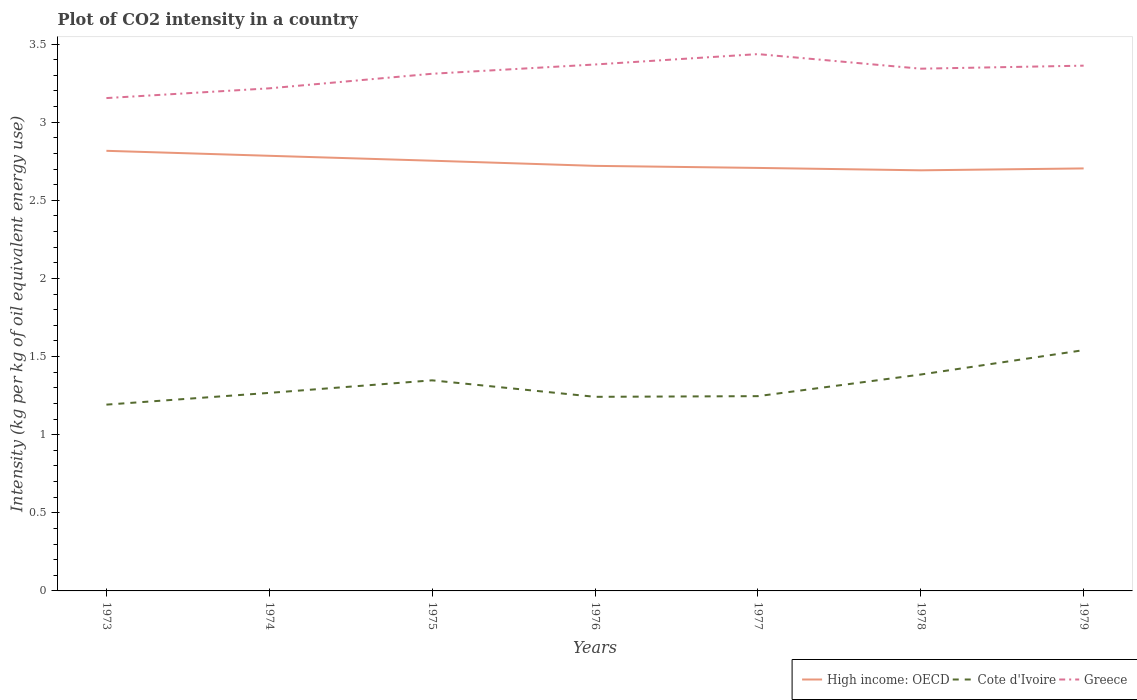Does the line corresponding to Greece intersect with the line corresponding to High income: OECD?
Keep it short and to the point. No. Across all years, what is the maximum CO2 intensity in in High income: OECD?
Your answer should be very brief. 2.69. In which year was the CO2 intensity in in Greece maximum?
Make the answer very short. 1973. What is the total CO2 intensity in in Greece in the graph?
Make the answer very short. 0.07. What is the difference between the highest and the second highest CO2 intensity in in Cote d'Ivoire?
Make the answer very short. 0.35. What is the difference between the highest and the lowest CO2 intensity in in Cote d'Ivoire?
Your response must be concise. 3. Is the CO2 intensity in in Cote d'Ivoire strictly greater than the CO2 intensity in in Greece over the years?
Your response must be concise. Yes. How many lines are there?
Provide a short and direct response. 3. Does the graph contain grids?
Your answer should be very brief. No. What is the title of the graph?
Ensure brevity in your answer.  Plot of CO2 intensity in a country. Does "Rwanda" appear as one of the legend labels in the graph?
Make the answer very short. No. What is the label or title of the X-axis?
Give a very brief answer. Years. What is the label or title of the Y-axis?
Your answer should be compact. Intensity (kg per kg of oil equivalent energy use). What is the Intensity (kg per kg of oil equivalent energy use) in High income: OECD in 1973?
Give a very brief answer. 2.82. What is the Intensity (kg per kg of oil equivalent energy use) in Cote d'Ivoire in 1973?
Your response must be concise. 1.19. What is the Intensity (kg per kg of oil equivalent energy use) of Greece in 1973?
Offer a terse response. 3.15. What is the Intensity (kg per kg of oil equivalent energy use) in High income: OECD in 1974?
Offer a terse response. 2.78. What is the Intensity (kg per kg of oil equivalent energy use) in Cote d'Ivoire in 1974?
Offer a terse response. 1.27. What is the Intensity (kg per kg of oil equivalent energy use) of Greece in 1974?
Offer a very short reply. 3.22. What is the Intensity (kg per kg of oil equivalent energy use) of High income: OECD in 1975?
Your answer should be very brief. 2.75. What is the Intensity (kg per kg of oil equivalent energy use) of Cote d'Ivoire in 1975?
Make the answer very short. 1.35. What is the Intensity (kg per kg of oil equivalent energy use) of Greece in 1975?
Offer a terse response. 3.31. What is the Intensity (kg per kg of oil equivalent energy use) of High income: OECD in 1976?
Offer a terse response. 2.72. What is the Intensity (kg per kg of oil equivalent energy use) in Cote d'Ivoire in 1976?
Keep it short and to the point. 1.24. What is the Intensity (kg per kg of oil equivalent energy use) of Greece in 1976?
Keep it short and to the point. 3.37. What is the Intensity (kg per kg of oil equivalent energy use) of High income: OECD in 1977?
Keep it short and to the point. 2.71. What is the Intensity (kg per kg of oil equivalent energy use) in Cote d'Ivoire in 1977?
Provide a succinct answer. 1.25. What is the Intensity (kg per kg of oil equivalent energy use) of Greece in 1977?
Provide a short and direct response. 3.44. What is the Intensity (kg per kg of oil equivalent energy use) of High income: OECD in 1978?
Provide a short and direct response. 2.69. What is the Intensity (kg per kg of oil equivalent energy use) of Cote d'Ivoire in 1978?
Your response must be concise. 1.39. What is the Intensity (kg per kg of oil equivalent energy use) of Greece in 1978?
Ensure brevity in your answer.  3.34. What is the Intensity (kg per kg of oil equivalent energy use) in High income: OECD in 1979?
Your response must be concise. 2.7. What is the Intensity (kg per kg of oil equivalent energy use) in Cote d'Ivoire in 1979?
Provide a succinct answer. 1.54. What is the Intensity (kg per kg of oil equivalent energy use) of Greece in 1979?
Offer a very short reply. 3.36. Across all years, what is the maximum Intensity (kg per kg of oil equivalent energy use) of High income: OECD?
Make the answer very short. 2.82. Across all years, what is the maximum Intensity (kg per kg of oil equivalent energy use) of Cote d'Ivoire?
Offer a very short reply. 1.54. Across all years, what is the maximum Intensity (kg per kg of oil equivalent energy use) in Greece?
Give a very brief answer. 3.44. Across all years, what is the minimum Intensity (kg per kg of oil equivalent energy use) in High income: OECD?
Make the answer very short. 2.69. Across all years, what is the minimum Intensity (kg per kg of oil equivalent energy use) in Cote d'Ivoire?
Your answer should be very brief. 1.19. Across all years, what is the minimum Intensity (kg per kg of oil equivalent energy use) in Greece?
Your answer should be very brief. 3.15. What is the total Intensity (kg per kg of oil equivalent energy use) of High income: OECD in the graph?
Offer a terse response. 19.18. What is the total Intensity (kg per kg of oil equivalent energy use) in Cote d'Ivoire in the graph?
Your answer should be very brief. 9.22. What is the total Intensity (kg per kg of oil equivalent energy use) in Greece in the graph?
Ensure brevity in your answer.  23.19. What is the difference between the Intensity (kg per kg of oil equivalent energy use) of High income: OECD in 1973 and that in 1974?
Your response must be concise. 0.03. What is the difference between the Intensity (kg per kg of oil equivalent energy use) in Cote d'Ivoire in 1973 and that in 1974?
Offer a terse response. -0.08. What is the difference between the Intensity (kg per kg of oil equivalent energy use) in Greece in 1973 and that in 1974?
Your answer should be very brief. -0.06. What is the difference between the Intensity (kg per kg of oil equivalent energy use) in High income: OECD in 1973 and that in 1975?
Your response must be concise. 0.06. What is the difference between the Intensity (kg per kg of oil equivalent energy use) of Cote d'Ivoire in 1973 and that in 1975?
Give a very brief answer. -0.16. What is the difference between the Intensity (kg per kg of oil equivalent energy use) of Greece in 1973 and that in 1975?
Your answer should be very brief. -0.16. What is the difference between the Intensity (kg per kg of oil equivalent energy use) in High income: OECD in 1973 and that in 1976?
Offer a terse response. 0.1. What is the difference between the Intensity (kg per kg of oil equivalent energy use) of Cote d'Ivoire in 1973 and that in 1976?
Your answer should be compact. -0.05. What is the difference between the Intensity (kg per kg of oil equivalent energy use) in Greece in 1973 and that in 1976?
Provide a succinct answer. -0.21. What is the difference between the Intensity (kg per kg of oil equivalent energy use) of High income: OECD in 1973 and that in 1977?
Give a very brief answer. 0.11. What is the difference between the Intensity (kg per kg of oil equivalent energy use) in Cote d'Ivoire in 1973 and that in 1977?
Make the answer very short. -0.05. What is the difference between the Intensity (kg per kg of oil equivalent energy use) in Greece in 1973 and that in 1977?
Your answer should be very brief. -0.28. What is the difference between the Intensity (kg per kg of oil equivalent energy use) in High income: OECD in 1973 and that in 1978?
Give a very brief answer. 0.12. What is the difference between the Intensity (kg per kg of oil equivalent energy use) in Cote d'Ivoire in 1973 and that in 1978?
Provide a succinct answer. -0.19. What is the difference between the Intensity (kg per kg of oil equivalent energy use) in Greece in 1973 and that in 1978?
Your answer should be very brief. -0.19. What is the difference between the Intensity (kg per kg of oil equivalent energy use) in High income: OECD in 1973 and that in 1979?
Ensure brevity in your answer.  0.11. What is the difference between the Intensity (kg per kg of oil equivalent energy use) of Cote d'Ivoire in 1973 and that in 1979?
Your answer should be compact. -0.35. What is the difference between the Intensity (kg per kg of oil equivalent energy use) in Greece in 1973 and that in 1979?
Make the answer very short. -0.21. What is the difference between the Intensity (kg per kg of oil equivalent energy use) in High income: OECD in 1974 and that in 1975?
Your answer should be compact. 0.03. What is the difference between the Intensity (kg per kg of oil equivalent energy use) in Cote d'Ivoire in 1974 and that in 1975?
Offer a terse response. -0.08. What is the difference between the Intensity (kg per kg of oil equivalent energy use) of Greece in 1974 and that in 1975?
Ensure brevity in your answer.  -0.09. What is the difference between the Intensity (kg per kg of oil equivalent energy use) in High income: OECD in 1974 and that in 1976?
Ensure brevity in your answer.  0.06. What is the difference between the Intensity (kg per kg of oil equivalent energy use) in Cote d'Ivoire in 1974 and that in 1976?
Your response must be concise. 0.03. What is the difference between the Intensity (kg per kg of oil equivalent energy use) of Greece in 1974 and that in 1976?
Your answer should be compact. -0.15. What is the difference between the Intensity (kg per kg of oil equivalent energy use) of High income: OECD in 1974 and that in 1977?
Keep it short and to the point. 0.08. What is the difference between the Intensity (kg per kg of oil equivalent energy use) of Cote d'Ivoire in 1974 and that in 1977?
Offer a terse response. 0.02. What is the difference between the Intensity (kg per kg of oil equivalent energy use) in Greece in 1974 and that in 1977?
Offer a terse response. -0.22. What is the difference between the Intensity (kg per kg of oil equivalent energy use) in High income: OECD in 1974 and that in 1978?
Your answer should be compact. 0.09. What is the difference between the Intensity (kg per kg of oil equivalent energy use) of Cote d'Ivoire in 1974 and that in 1978?
Your answer should be very brief. -0.12. What is the difference between the Intensity (kg per kg of oil equivalent energy use) in Greece in 1974 and that in 1978?
Your response must be concise. -0.13. What is the difference between the Intensity (kg per kg of oil equivalent energy use) in High income: OECD in 1974 and that in 1979?
Make the answer very short. 0.08. What is the difference between the Intensity (kg per kg of oil equivalent energy use) of Cote d'Ivoire in 1974 and that in 1979?
Make the answer very short. -0.27. What is the difference between the Intensity (kg per kg of oil equivalent energy use) of Greece in 1974 and that in 1979?
Keep it short and to the point. -0.15. What is the difference between the Intensity (kg per kg of oil equivalent energy use) of High income: OECD in 1975 and that in 1976?
Ensure brevity in your answer.  0.03. What is the difference between the Intensity (kg per kg of oil equivalent energy use) in Cote d'Ivoire in 1975 and that in 1976?
Your answer should be compact. 0.11. What is the difference between the Intensity (kg per kg of oil equivalent energy use) of Greece in 1975 and that in 1976?
Your answer should be very brief. -0.06. What is the difference between the Intensity (kg per kg of oil equivalent energy use) in High income: OECD in 1975 and that in 1977?
Provide a succinct answer. 0.05. What is the difference between the Intensity (kg per kg of oil equivalent energy use) in Cote d'Ivoire in 1975 and that in 1977?
Make the answer very short. 0.1. What is the difference between the Intensity (kg per kg of oil equivalent energy use) of Greece in 1975 and that in 1977?
Provide a succinct answer. -0.13. What is the difference between the Intensity (kg per kg of oil equivalent energy use) of High income: OECD in 1975 and that in 1978?
Give a very brief answer. 0.06. What is the difference between the Intensity (kg per kg of oil equivalent energy use) of Cote d'Ivoire in 1975 and that in 1978?
Your answer should be very brief. -0.04. What is the difference between the Intensity (kg per kg of oil equivalent energy use) of Greece in 1975 and that in 1978?
Provide a short and direct response. -0.03. What is the difference between the Intensity (kg per kg of oil equivalent energy use) in High income: OECD in 1975 and that in 1979?
Provide a succinct answer. 0.05. What is the difference between the Intensity (kg per kg of oil equivalent energy use) of Cote d'Ivoire in 1975 and that in 1979?
Give a very brief answer. -0.19. What is the difference between the Intensity (kg per kg of oil equivalent energy use) of Greece in 1975 and that in 1979?
Your answer should be compact. -0.05. What is the difference between the Intensity (kg per kg of oil equivalent energy use) in High income: OECD in 1976 and that in 1977?
Ensure brevity in your answer.  0.01. What is the difference between the Intensity (kg per kg of oil equivalent energy use) of Cote d'Ivoire in 1976 and that in 1977?
Ensure brevity in your answer.  -0. What is the difference between the Intensity (kg per kg of oil equivalent energy use) of Greece in 1976 and that in 1977?
Offer a very short reply. -0.07. What is the difference between the Intensity (kg per kg of oil equivalent energy use) in High income: OECD in 1976 and that in 1978?
Offer a terse response. 0.03. What is the difference between the Intensity (kg per kg of oil equivalent energy use) of Cote d'Ivoire in 1976 and that in 1978?
Provide a succinct answer. -0.14. What is the difference between the Intensity (kg per kg of oil equivalent energy use) in Greece in 1976 and that in 1978?
Make the answer very short. 0.03. What is the difference between the Intensity (kg per kg of oil equivalent energy use) in High income: OECD in 1976 and that in 1979?
Your answer should be very brief. 0.02. What is the difference between the Intensity (kg per kg of oil equivalent energy use) in Cote d'Ivoire in 1976 and that in 1979?
Give a very brief answer. -0.3. What is the difference between the Intensity (kg per kg of oil equivalent energy use) of Greece in 1976 and that in 1979?
Provide a short and direct response. 0.01. What is the difference between the Intensity (kg per kg of oil equivalent energy use) of High income: OECD in 1977 and that in 1978?
Offer a very short reply. 0.02. What is the difference between the Intensity (kg per kg of oil equivalent energy use) of Cote d'Ivoire in 1977 and that in 1978?
Keep it short and to the point. -0.14. What is the difference between the Intensity (kg per kg of oil equivalent energy use) of Greece in 1977 and that in 1978?
Make the answer very short. 0.09. What is the difference between the Intensity (kg per kg of oil equivalent energy use) of High income: OECD in 1977 and that in 1979?
Your answer should be very brief. 0. What is the difference between the Intensity (kg per kg of oil equivalent energy use) of Cote d'Ivoire in 1977 and that in 1979?
Give a very brief answer. -0.29. What is the difference between the Intensity (kg per kg of oil equivalent energy use) of Greece in 1977 and that in 1979?
Keep it short and to the point. 0.07. What is the difference between the Intensity (kg per kg of oil equivalent energy use) of High income: OECD in 1978 and that in 1979?
Your answer should be very brief. -0.01. What is the difference between the Intensity (kg per kg of oil equivalent energy use) of Cote d'Ivoire in 1978 and that in 1979?
Offer a terse response. -0.16. What is the difference between the Intensity (kg per kg of oil equivalent energy use) in Greece in 1978 and that in 1979?
Offer a very short reply. -0.02. What is the difference between the Intensity (kg per kg of oil equivalent energy use) in High income: OECD in 1973 and the Intensity (kg per kg of oil equivalent energy use) in Cote d'Ivoire in 1974?
Your answer should be compact. 1.55. What is the difference between the Intensity (kg per kg of oil equivalent energy use) of High income: OECD in 1973 and the Intensity (kg per kg of oil equivalent energy use) of Greece in 1974?
Your answer should be very brief. -0.4. What is the difference between the Intensity (kg per kg of oil equivalent energy use) in Cote d'Ivoire in 1973 and the Intensity (kg per kg of oil equivalent energy use) in Greece in 1974?
Offer a terse response. -2.02. What is the difference between the Intensity (kg per kg of oil equivalent energy use) of High income: OECD in 1973 and the Intensity (kg per kg of oil equivalent energy use) of Cote d'Ivoire in 1975?
Your answer should be very brief. 1.47. What is the difference between the Intensity (kg per kg of oil equivalent energy use) in High income: OECD in 1973 and the Intensity (kg per kg of oil equivalent energy use) in Greece in 1975?
Your answer should be compact. -0.49. What is the difference between the Intensity (kg per kg of oil equivalent energy use) in Cote d'Ivoire in 1973 and the Intensity (kg per kg of oil equivalent energy use) in Greece in 1975?
Provide a short and direct response. -2.12. What is the difference between the Intensity (kg per kg of oil equivalent energy use) in High income: OECD in 1973 and the Intensity (kg per kg of oil equivalent energy use) in Cote d'Ivoire in 1976?
Ensure brevity in your answer.  1.57. What is the difference between the Intensity (kg per kg of oil equivalent energy use) in High income: OECD in 1973 and the Intensity (kg per kg of oil equivalent energy use) in Greece in 1976?
Provide a succinct answer. -0.55. What is the difference between the Intensity (kg per kg of oil equivalent energy use) in Cote d'Ivoire in 1973 and the Intensity (kg per kg of oil equivalent energy use) in Greece in 1976?
Make the answer very short. -2.18. What is the difference between the Intensity (kg per kg of oil equivalent energy use) in High income: OECD in 1973 and the Intensity (kg per kg of oil equivalent energy use) in Cote d'Ivoire in 1977?
Offer a very short reply. 1.57. What is the difference between the Intensity (kg per kg of oil equivalent energy use) of High income: OECD in 1973 and the Intensity (kg per kg of oil equivalent energy use) of Greece in 1977?
Offer a very short reply. -0.62. What is the difference between the Intensity (kg per kg of oil equivalent energy use) in Cote d'Ivoire in 1973 and the Intensity (kg per kg of oil equivalent energy use) in Greece in 1977?
Offer a terse response. -2.24. What is the difference between the Intensity (kg per kg of oil equivalent energy use) in High income: OECD in 1973 and the Intensity (kg per kg of oil equivalent energy use) in Cote d'Ivoire in 1978?
Give a very brief answer. 1.43. What is the difference between the Intensity (kg per kg of oil equivalent energy use) in High income: OECD in 1973 and the Intensity (kg per kg of oil equivalent energy use) in Greece in 1978?
Make the answer very short. -0.53. What is the difference between the Intensity (kg per kg of oil equivalent energy use) of Cote d'Ivoire in 1973 and the Intensity (kg per kg of oil equivalent energy use) of Greece in 1978?
Provide a short and direct response. -2.15. What is the difference between the Intensity (kg per kg of oil equivalent energy use) in High income: OECD in 1973 and the Intensity (kg per kg of oil equivalent energy use) in Cote d'Ivoire in 1979?
Your answer should be compact. 1.28. What is the difference between the Intensity (kg per kg of oil equivalent energy use) of High income: OECD in 1973 and the Intensity (kg per kg of oil equivalent energy use) of Greece in 1979?
Provide a short and direct response. -0.55. What is the difference between the Intensity (kg per kg of oil equivalent energy use) in Cote d'Ivoire in 1973 and the Intensity (kg per kg of oil equivalent energy use) in Greece in 1979?
Provide a short and direct response. -2.17. What is the difference between the Intensity (kg per kg of oil equivalent energy use) of High income: OECD in 1974 and the Intensity (kg per kg of oil equivalent energy use) of Cote d'Ivoire in 1975?
Offer a very short reply. 1.44. What is the difference between the Intensity (kg per kg of oil equivalent energy use) in High income: OECD in 1974 and the Intensity (kg per kg of oil equivalent energy use) in Greece in 1975?
Offer a very short reply. -0.53. What is the difference between the Intensity (kg per kg of oil equivalent energy use) of Cote d'Ivoire in 1974 and the Intensity (kg per kg of oil equivalent energy use) of Greece in 1975?
Your response must be concise. -2.04. What is the difference between the Intensity (kg per kg of oil equivalent energy use) of High income: OECD in 1974 and the Intensity (kg per kg of oil equivalent energy use) of Cote d'Ivoire in 1976?
Your answer should be very brief. 1.54. What is the difference between the Intensity (kg per kg of oil equivalent energy use) in High income: OECD in 1974 and the Intensity (kg per kg of oil equivalent energy use) in Greece in 1976?
Ensure brevity in your answer.  -0.58. What is the difference between the Intensity (kg per kg of oil equivalent energy use) of Cote d'Ivoire in 1974 and the Intensity (kg per kg of oil equivalent energy use) of Greece in 1976?
Make the answer very short. -2.1. What is the difference between the Intensity (kg per kg of oil equivalent energy use) of High income: OECD in 1974 and the Intensity (kg per kg of oil equivalent energy use) of Cote d'Ivoire in 1977?
Your answer should be compact. 1.54. What is the difference between the Intensity (kg per kg of oil equivalent energy use) of High income: OECD in 1974 and the Intensity (kg per kg of oil equivalent energy use) of Greece in 1977?
Provide a short and direct response. -0.65. What is the difference between the Intensity (kg per kg of oil equivalent energy use) in Cote d'Ivoire in 1974 and the Intensity (kg per kg of oil equivalent energy use) in Greece in 1977?
Your answer should be very brief. -2.17. What is the difference between the Intensity (kg per kg of oil equivalent energy use) in High income: OECD in 1974 and the Intensity (kg per kg of oil equivalent energy use) in Cote d'Ivoire in 1978?
Offer a very short reply. 1.4. What is the difference between the Intensity (kg per kg of oil equivalent energy use) of High income: OECD in 1974 and the Intensity (kg per kg of oil equivalent energy use) of Greece in 1978?
Your answer should be very brief. -0.56. What is the difference between the Intensity (kg per kg of oil equivalent energy use) in Cote d'Ivoire in 1974 and the Intensity (kg per kg of oil equivalent energy use) in Greece in 1978?
Ensure brevity in your answer.  -2.08. What is the difference between the Intensity (kg per kg of oil equivalent energy use) in High income: OECD in 1974 and the Intensity (kg per kg of oil equivalent energy use) in Cote d'Ivoire in 1979?
Give a very brief answer. 1.24. What is the difference between the Intensity (kg per kg of oil equivalent energy use) of High income: OECD in 1974 and the Intensity (kg per kg of oil equivalent energy use) of Greece in 1979?
Your answer should be very brief. -0.58. What is the difference between the Intensity (kg per kg of oil equivalent energy use) of Cote d'Ivoire in 1974 and the Intensity (kg per kg of oil equivalent energy use) of Greece in 1979?
Your answer should be very brief. -2.09. What is the difference between the Intensity (kg per kg of oil equivalent energy use) in High income: OECD in 1975 and the Intensity (kg per kg of oil equivalent energy use) in Cote d'Ivoire in 1976?
Your answer should be very brief. 1.51. What is the difference between the Intensity (kg per kg of oil equivalent energy use) of High income: OECD in 1975 and the Intensity (kg per kg of oil equivalent energy use) of Greece in 1976?
Offer a terse response. -0.62. What is the difference between the Intensity (kg per kg of oil equivalent energy use) in Cote d'Ivoire in 1975 and the Intensity (kg per kg of oil equivalent energy use) in Greece in 1976?
Keep it short and to the point. -2.02. What is the difference between the Intensity (kg per kg of oil equivalent energy use) in High income: OECD in 1975 and the Intensity (kg per kg of oil equivalent energy use) in Cote d'Ivoire in 1977?
Ensure brevity in your answer.  1.51. What is the difference between the Intensity (kg per kg of oil equivalent energy use) in High income: OECD in 1975 and the Intensity (kg per kg of oil equivalent energy use) in Greece in 1977?
Your response must be concise. -0.68. What is the difference between the Intensity (kg per kg of oil equivalent energy use) in Cote d'Ivoire in 1975 and the Intensity (kg per kg of oil equivalent energy use) in Greece in 1977?
Provide a short and direct response. -2.09. What is the difference between the Intensity (kg per kg of oil equivalent energy use) of High income: OECD in 1975 and the Intensity (kg per kg of oil equivalent energy use) of Cote d'Ivoire in 1978?
Your answer should be very brief. 1.37. What is the difference between the Intensity (kg per kg of oil equivalent energy use) in High income: OECD in 1975 and the Intensity (kg per kg of oil equivalent energy use) in Greece in 1978?
Make the answer very short. -0.59. What is the difference between the Intensity (kg per kg of oil equivalent energy use) in Cote d'Ivoire in 1975 and the Intensity (kg per kg of oil equivalent energy use) in Greece in 1978?
Give a very brief answer. -1.99. What is the difference between the Intensity (kg per kg of oil equivalent energy use) in High income: OECD in 1975 and the Intensity (kg per kg of oil equivalent energy use) in Cote d'Ivoire in 1979?
Make the answer very short. 1.21. What is the difference between the Intensity (kg per kg of oil equivalent energy use) of High income: OECD in 1975 and the Intensity (kg per kg of oil equivalent energy use) of Greece in 1979?
Make the answer very short. -0.61. What is the difference between the Intensity (kg per kg of oil equivalent energy use) of Cote d'Ivoire in 1975 and the Intensity (kg per kg of oil equivalent energy use) of Greece in 1979?
Give a very brief answer. -2.01. What is the difference between the Intensity (kg per kg of oil equivalent energy use) of High income: OECD in 1976 and the Intensity (kg per kg of oil equivalent energy use) of Cote d'Ivoire in 1977?
Ensure brevity in your answer.  1.47. What is the difference between the Intensity (kg per kg of oil equivalent energy use) of High income: OECD in 1976 and the Intensity (kg per kg of oil equivalent energy use) of Greece in 1977?
Your response must be concise. -0.72. What is the difference between the Intensity (kg per kg of oil equivalent energy use) of Cote d'Ivoire in 1976 and the Intensity (kg per kg of oil equivalent energy use) of Greece in 1977?
Make the answer very short. -2.19. What is the difference between the Intensity (kg per kg of oil equivalent energy use) in High income: OECD in 1976 and the Intensity (kg per kg of oil equivalent energy use) in Cote d'Ivoire in 1978?
Your response must be concise. 1.34. What is the difference between the Intensity (kg per kg of oil equivalent energy use) in High income: OECD in 1976 and the Intensity (kg per kg of oil equivalent energy use) in Greece in 1978?
Ensure brevity in your answer.  -0.62. What is the difference between the Intensity (kg per kg of oil equivalent energy use) of Cote d'Ivoire in 1976 and the Intensity (kg per kg of oil equivalent energy use) of Greece in 1978?
Your answer should be compact. -2.1. What is the difference between the Intensity (kg per kg of oil equivalent energy use) of High income: OECD in 1976 and the Intensity (kg per kg of oil equivalent energy use) of Cote d'Ivoire in 1979?
Provide a succinct answer. 1.18. What is the difference between the Intensity (kg per kg of oil equivalent energy use) of High income: OECD in 1976 and the Intensity (kg per kg of oil equivalent energy use) of Greece in 1979?
Give a very brief answer. -0.64. What is the difference between the Intensity (kg per kg of oil equivalent energy use) of Cote d'Ivoire in 1976 and the Intensity (kg per kg of oil equivalent energy use) of Greece in 1979?
Your response must be concise. -2.12. What is the difference between the Intensity (kg per kg of oil equivalent energy use) of High income: OECD in 1977 and the Intensity (kg per kg of oil equivalent energy use) of Cote d'Ivoire in 1978?
Offer a terse response. 1.32. What is the difference between the Intensity (kg per kg of oil equivalent energy use) in High income: OECD in 1977 and the Intensity (kg per kg of oil equivalent energy use) in Greece in 1978?
Your answer should be compact. -0.64. What is the difference between the Intensity (kg per kg of oil equivalent energy use) in Cote d'Ivoire in 1977 and the Intensity (kg per kg of oil equivalent energy use) in Greece in 1978?
Your answer should be compact. -2.1. What is the difference between the Intensity (kg per kg of oil equivalent energy use) in High income: OECD in 1977 and the Intensity (kg per kg of oil equivalent energy use) in Cote d'Ivoire in 1979?
Offer a very short reply. 1.17. What is the difference between the Intensity (kg per kg of oil equivalent energy use) in High income: OECD in 1977 and the Intensity (kg per kg of oil equivalent energy use) in Greece in 1979?
Ensure brevity in your answer.  -0.65. What is the difference between the Intensity (kg per kg of oil equivalent energy use) in Cote d'Ivoire in 1977 and the Intensity (kg per kg of oil equivalent energy use) in Greece in 1979?
Make the answer very short. -2.12. What is the difference between the Intensity (kg per kg of oil equivalent energy use) in High income: OECD in 1978 and the Intensity (kg per kg of oil equivalent energy use) in Cote d'Ivoire in 1979?
Keep it short and to the point. 1.15. What is the difference between the Intensity (kg per kg of oil equivalent energy use) of High income: OECD in 1978 and the Intensity (kg per kg of oil equivalent energy use) of Greece in 1979?
Give a very brief answer. -0.67. What is the difference between the Intensity (kg per kg of oil equivalent energy use) of Cote d'Ivoire in 1978 and the Intensity (kg per kg of oil equivalent energy use) of Greece in 1979?
Offer a terse response. -1.98. What is the average Intensity (kg per kg of oil equivalent energy use) in High income: OECD per year?
Provide a succinct answer. 2.74. What is the average Intensity (kg per kg of oil equivalent energy use) in Cote d'Ivoire per year?
Your answer should be very brief. 1.32. What is the average Intensity (kg per kg of oil equivalent energy use) in Greece per year?
Ensure brevity in your answer.  3.31. In the year 1973, what is the difference between the Intensity (kg per kg of oil equivalent energy use) of High income: OECD and Intensity (kg per kg of oil equivalent energy use) of Cote d'Ivoire?
Your answer should be very brief. 1.62. In the year 1973, what is the difference between the Intensity (kg per kg of oil equivalent energy use) in High income: OECD and Intensity (kg per kg of oil equivalent energy use) in Greece?
Keep it short and to the point. -0.34. In the year 1973, what is the difference between the Intensity (kg per kg of oil equivalent energy use) in Cote d'Ivoire and Intensity (kg per kg of oil equivalent energy use) in Greece?
Provide a short and direct response. -1.96. In the year 1974, what is the difference between the Intensity (kg per kg of oil equivalent energy use) in High income: OECD and Intensity (kg per kg of oil equivalent energy use) in Cote d'Ivoire?
Ensure brevity in your answer.  1.52. In the year 1974, what is the difference between the Intensity (kg per kg of oil equivalent energy use) in High income: OECD and Intensity (kg per kg of oil equivalent energy use) in Greece?
Ensure brevity in your answer.  -0.43. In the year 1974, what is the difference between the Intensity (kg per kg of oil equivalent energy use) in Cote d'Ivoire and Intensity (kg per kg of oil equivalent energy use) in Greece?
Ensure brevity in your answer.  -1.95. In the year 1975, what is the difference between the Intensity (kg per kg of oil equivalent energy use) in High income: OECD and Intensity (kg per kg of oil equivalent energy use) in Cote d'Ivoire?
Provide a short and direct response. 1.41. In the year 1975, what is the difference between the Intensity (kg per kg of oil equivalent energy use) in High income: OECD and Intensity (kg per kg of oil equivalent energy use) in Greece?
Your response must be concise. -0.56. In the year 1975, what is the difference between the Intensity (kg per kg of oil equivalent energy use) in Cote d'Ivoire and Intensity (kg per kg of oil equivalent energy use) in Greece?
Ensure brevity in your answer.  -1.96. In the year 1976, what is the difference between the Intensity (kg per kg of oil equivalent energy use) in High income: OECD and Intensity (kg per kg of oil equivalent energy use) in Cote d'Ivoire?
Offer a terse response. 1.48. In the year 1976, what is the difference between the Intensity (kg per kg of oil equivalent energy use) of High income: OECD and Intensity (kg per kg of oil equivalent energy use) of Greece?
Provide a short and direct response. -0.65. In the year 1976, what is the difference between the Intensity (kg per kg of oil equivalent energy use) in Cote d'Ivoire and Intensity (kg per kg of oil equivalent energy use) in Greece?
Make the answer very short. -2.13. In the year 1977, what is the difference between the Intensity (kg per kg of oil equivalent energy use) of High income: OECD and Intensity (kg per kg of oil equivalent energy use) of Cote d'Ivoire?
Provide a succinct answer. 1.46. In the year 1977, what is the difference between the Intensity (kg per kg of oil equivalent energy use) in High income: OECD and Intensity (kg per kg of oil equivalent energy use) in Greece?
Your response must be concise. -0.73. In the year 1977, what is the difference between the Intensity (kg per kg of oil equivalent energy use) in Cote d'Ivoire and Intensity (kg per kg of oil equivalent energy use) in Greece?
Give a very brief answer. -2.19. In the year 1978, what is the difference between the Intensity (kg per kg of oil equivalent energy use) in High income: OECD and Intensity (kg per kg of oil equivalent energy use) in Cote d'Ivoire?
Provide a succinct answer. 1.31. In the year 1978, what is the difference between the Intensity (kg per kg of oil equivalent energy use) in High income: OECD and Intensity (kg per kg of oil equivalent energy use) in Greece?
Offer a very short reply. -0.65. In the year 1978, what is the difference between the Intensity (kg per kg of oil equivalent energy use) in Cote d'Ivoire and Intensity (kg per kg of oil equivalent energy use) in Greece?
Give a very brief answer. -1.96. In the year 1979, what is the difference between the Intensity (kg per kg of oil equivalent energy use) in High income: OECD and Intensity (kg per kg of oil equivalent energy use) in Cote d'Ivoire?
Your answer should be compact. 1.16. In the year 1979, what is the difference between the Intensity (kg per kg of oil equivalent energy use) in High income: OECD and Intensity (kg per kg of oil equivalent energy use) in Greece?
Your answer should be very brief. -0.66. In the year 1979, what is the difference between the Intensity (kg per kg of oil equivalent energy use) in Cote d'Ivoire and Intensity (kg per kg of oil equivalent energy use) in Greece?
Make the answer very short. -1.82. What is the ratio of the Intensity (kg per kg of oil equivalent energy use) of High income: OECD in 1973 to that in 1974?
Your answer should be compact. 1.01. What is the ratio of the Intensity (kg per kg of oil equivalent energy use) in Cote d'Ivoire in 1973 to that in 1974?
Provide a short and direct response. 0.94. What is the ratio of the Intensity (kg per kg of oil equivalent energy use) in Greece in 1973 to that in 1974?
Your response must be concise. 0.98. What is the ratio of the Intensity (kg per kg of oil equivalent energy use) in Cote d'Ivoire in 1973 to that in 1975?
Your answer should be compact. 0.88. What is the ratio of the Intensity (kg per kg of oil equivalent energy use) in Greece in 1973 to that in 1975?
Offer a very short reply. 0.95. What is the ratio of the Intensity (kg per kg of oil equivalent energy use) of High income: OECD in 1973 to that in 1976?
Offer a very short reply. 1.04. What is the ratio of the Intensity (kg per kg of oil equivalent energy use) in Cote d'Ivoire in 1973 to that in 1976?
Provide a succinct answer. 0.96. What is the ratio of the Intensity (kg per kg of oil equivalent energy use) in Greece in 1973 to that in 1976?
Provide a succinct answer. 0.94. What is the ratio of the Intensity (kg per kg of oil equivalent energy use) in High income: OECD in 1973 to that in 1977?
Keep it short and to the point. 1.04. What is the ratio of the Intensity (kg per kg of oil equivalent energy use) of Cote d'Ivoire in 1973 to that in 1977?
Your response must be concise. 0.96. What is the ratio of the Intensity (kg per kg of oil equivalent energy use) in Greece in 1973 to that in 1977?
Your answer should be compact. 0.92. What is the ratio of the Intensity (kg per kg of oil equivalent energy use) of High income: OECD in 1973 to that in 1978?
Ensure brevity in your answer.  1.05. What is the ratio of the Intensity (kg per kg of oil equivalent energy use) of Cote d'Ivoire in 1973 to that in 1978?
Offer a terse response. 0.86. What is the ratio of the Intensity (kg per kg of oil equivalent energy use) in Greece in 1973 to that in 1978?
Ensure brevity in your answer.  0.94. What is the ratio of the Intensity (kg per kg of oil equivalent energy use) in High income: OECD in 1973 to that in 1979?
Offer a very short reply. 1.04. What is the ratio of the Intensity (kg per kg of oil equivalent energy use) of Cote d'Ivoire in 1973 to that in 1979?
Offer a very short reply. 0.77. What is the ratio of the Intensity (kg per kg of oil equivalent energy use) in Greece in 1973 to that in 1979?
Give a very brief answer. 0.94. What is the ratio of the Intensity (kg per kg of oil equivalent energy use) in High income: OECD in 1974 to that in 1975?
Provide a succinct answer. 1.01. What is the ratio of the Intensity (kg per kg of oil equivalent energy use) in Cote d'Ivoire in 1974 to that in 1975?
Ensure brevity in your answer.  0.94. What is the ratio of the Intensity (kg per kg of oil equivalent energy use) of Greece in 1974 to that in 1975?
Give a very brief answer. 0.97. What is the ratio of the Intensity (kg per kg of oil equivalent energy use) in High income: OECD in 1974 to that in 1976?
Your response must be concise. 1.02. What is the ratio of the Intensity (kg per kg of oil equivalent energy use) of Cote d'Ivoire in 1974 to that in 1976?
Provide a succinct answer. 1.02. What is the ratio of the Intensity (kg per kg of oil equivalent energy use) of Greece in 1974 to that in 1976?
Offer a terse response. 0.95. What is the ratio of the Intensity (kg per kg of oil equivalent energy use) of High income: OECD in 1974 to that in 1977?
Provide a short and direct response. 1.03. What is the ratio of the Intensity (kg per kg of oil equivalent energy use) in Cote d'Ivoire in 1974 to that in 1977?
Your answer should be very brief. 1.02. What is the ratio of the Intensity (kg per kg of oil equivalent energy use) in Greece in 1974 to that in 1977?
Offer a very short reply. 0.94. What is the ratio of the Intensity (kg per kg of oil equivalent energy use) of High income: OECD in 1974 to that in 1978?
Your answer should be compact. 1.03. What is the ratio of the Intensity (kg per kg of oil equivalent energy use) in Cote d'Ivoire in 1974 to that in 1978?
Provide a short and direct response. 0.92. What is the ratio of the Intensity (kg per kg of oil equivalent energy use) of Greece in 1974 to that in 1978?
Give a very brief answer. 0.96. What is the ratio of the Intensity (kg per kg of oil equivalent energy use) of High income: OECD in 1974 to that in 1979?
Your answer should be compact. 1.03. What is the ratio of the Intensity (kg per kg of oil equivalent energy use) in Cote d'Ivoire in 1974 to that in 1979?
Offer a very short reply. 0.82. What is the ratio of the Intensity (kg per kg of oil equivalent energy use) of Greece in 1974 to that in 1979?
Give a very brief answer. 0.96. What is the ratio of the Intensity (kg per kg of oil equivalent energy use) in High income: OECD in 1975 to that in 1976?
Provide a short and direct response. 1.01. What is the ratio of the Intensity (kg per kg of oil equivalent energy use) in Cote d'Ivoire in 1975 to that in 1976?
Keep it short and to the point. 1.08. What is the ratio of the Intensity (kg per kg of oil equivalent energy use) of Greece in 1975 to that in 1976?
Offer a terse response. 0.98. What is the ratio of the Intensity (kg per kg of oil equivalent energy use) in High income: OECD in 1975 to that in 1977?
Provide a short and direct response. 1.02. What is the ratio of the Intensity (kg per kg of oil equivalent energy use) in Cote d'Ivoire in 1975 to that in 1977?
Give a very brief answer. 1.08. What is the ratio of the Intensity (kg per kg of oil equivalent energy use) of Greece in 1975 to that in 1977?
Offer a terse response. 0.96. What is the ratio of the Intensity (kg per kg of oil equivalent energy use) in High income: OECD in 1975 to that in 1978?
Your answer should be very brief. 1.02. What is the ratio of the Intensity (kg per kg of oil equivalent energy use) of Cote d'Ivoire in 1975 to that in 1978?
Make the answer very short. 0.97. What is the ratio of the Intensity (kg per kg of oil equivalent energy use) of Greece in 1975 to that in 1978?
Your response must be concise. 0.99. What is the ratio of the Intensity (kg per kg of oil equivalent energy use) of High income: OECD in 1975 to that in 1979?
Give a very brief answer. 1.02. What is the ratio of the Intensity (kg per kg of oil equivalent energy use) of Cote d'Ivoire in 1975 to that in 1979?
Your answer should be very brief. 0.87. What is the ratio of the Intensity (kg per kg of oil equivalent energy use) of Greece in 1975 to that in 1979?
Make the answer very short. 0.98. What is the ratio of the Intensity (kg per kg of oil equivalent energy use) in Greece in 1976 to that in 1977?
Offer a very short reply. 0.98. What is the ratio of the Intensity (kg per kg of oil equivalent energy use) in High income: OECD in 1976 to that in 1978?
Offer a very short reply. 1.01. What is the ratio of the Intensity (kg per kg of oil equivalent energy use) in Cote d'Ivoire in 1976 to that in 1978?
Ensure brevity in your answer.  0.9. What is the ratio of the Intensity (kg per kg of oil equivalent energy use) in Greece in 1976 to that in 1978?
Give a very brief answer. 1.01. What is the ratio of the Intensity (kg per kg of oil equivalent energy use) of Cote d'Ivoire in 1976 to that in 1979?
Make the answer very short. 0.81. What is the ratio of the Intensity (kg per kg of oil equivalent energy use) in Greece in 1976 to that in 1979?
Provide a short and direct response. 1. What is the ratio of the Intensity (kg per kg of oil equivalent energy use) of Cote d'Ivoire in 1977 to that in 1978?
Make the answer very short. 0.9. What is the ratio of the Intensity (kg per kg of oil equivalent energy use) in Greece in 1977 to that in 1978?
Keep it short and to the point. 1.03. What is the ratio of the Intensity (kg per kg of oil equivalent energy use) in Cote d'Ivoire in 1977 to that in 1979?
Offer a very short reply. 0.81. What is the ratio of the Intensity (kg per kg of oil equivalent energy use) in Cote d'Ivoire in 1978 to that in 1979?
Give a very brief answer. 0.9. What is the ratio of the Intensity (kg per kg of oil equivalent energy use) in Greece in 1978 to that in 1979?
Your response must be concise. 0.99. What is the difference between the highest and the second highest Intensity (kg per kg of oil equivalent energy use) of High income: OECD?
Make the answer very short. 0.03. What is the difference between the highest and the second highest Intensity (kg per kg of oil equivalent energy use) of Cote d'Ivoire?
Provide a short and direct response. 0.16. What is the difference between the highest and the second highest Intensity (kg per kg of oil equivalent energy use) in Greece?
Your response must be concise. 0.07. What is the difference between the highest and the lowest Intensity (kg per kg of oil equivalent energy use) of High income: OECD?
Offer a terse response. 0.12. What is the difference between the highest and the lowest Intensity (kg per kg of oil equivalent energy use) of Cote d'Ivoire?
Your response must be concise. 0.35. What is the difference between the highest and the lowest Intensity (kg per kg of oil equivalent energy use) of Greece?
Ensure brevity in your answer.  0.28. 